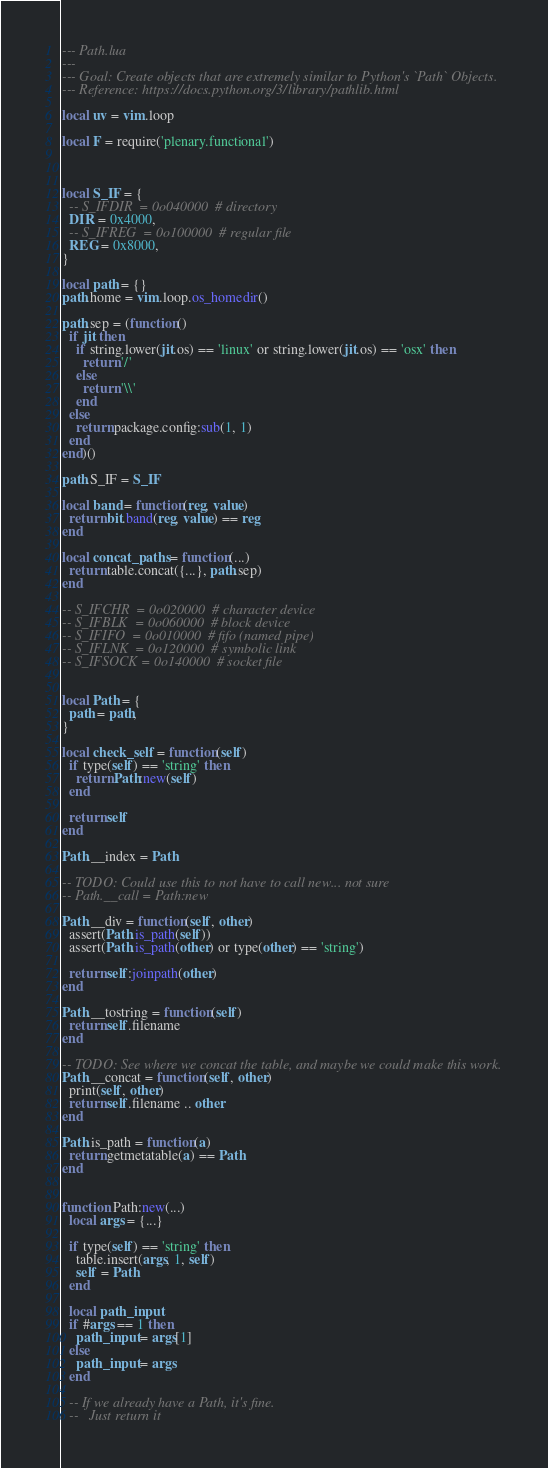Convert code to text. <code><loc_0><loc_0><loc_500><loc_500><_Lua_>--- Path.lua
---
--- Goal: Create objects that are extremely similar to Python's `Path` Objects.
--- Reference: https://docs.python.org/3/library/pathlib.html

local uv = vim.loop

local F = require('plenary.functional')



local S_IF = {
  -- S_IFDIR  = 0o040000  # directory
  DIR = 0x4000,
  -- S_IFREG  = 0o100000  # regular file
  REG = 0x8000,
}

local path = {}
path.home = vim.loop.os_homedir()

path.sep = (function()
  if jit then
    if string.lower(jit.os) == 'linux' or string.lower(jit.os) == 'osx' then
      return '/'
    else
      return '\\'
    end
  else
    return package.config:sub(1, 1)
  end
end)()

path.S_IF = S_IF

local band = function(reg, value)
  return bit.band(reg, value) == reg
end

local concat_paths = function(...)
  return table.concat({...}, path.sep)
end

-- S_IFCHR  = 0o020000  # character device
-- S_IFBLK  = 0o060000  # block device
-- S_IFIFO  = 0o010000  # fifo (named pipe)
-- S_IFLNK  = 0o120000  # symbolic link
-- S_IFSOCK = 0o140000  # socket file


local Path = {
  path = path,
}

local check_self = function(self)
  if type(self) == 'string' then
    return Path:new(self)
  end

  return self
end

Path.__index = Path

-- TODO: Could use this to not have to call new... not sure
-- Path.__call = Path:new

Path.__div = function(self, other)
  assert(Path.is_path(self))
  assert(Path.is_path(other) or type(other) == 'string')

  return self:joinpath(other)
end

Path.__tostring = function(self)
  return self.filename
end

-- TODO: See where we concat the table, and maybe we could make this work.
Path.__concat = function(self, other)
  print(self, other)
  return self.filename .. other
end

Path.is_path = function(a)
  return getmetatable(a) == Path
end


function Path:new(...)
  local args = {...}

  if type(self) == 'string' then
    table.insert(args, 1, self)
    self = Path
  end

  local path_input
  if #args == 1 then
    path_input = args[1]
  else
    path_input = args
  end

  -- If we already have a Path, it's fine.
  --   Just return it</code> 